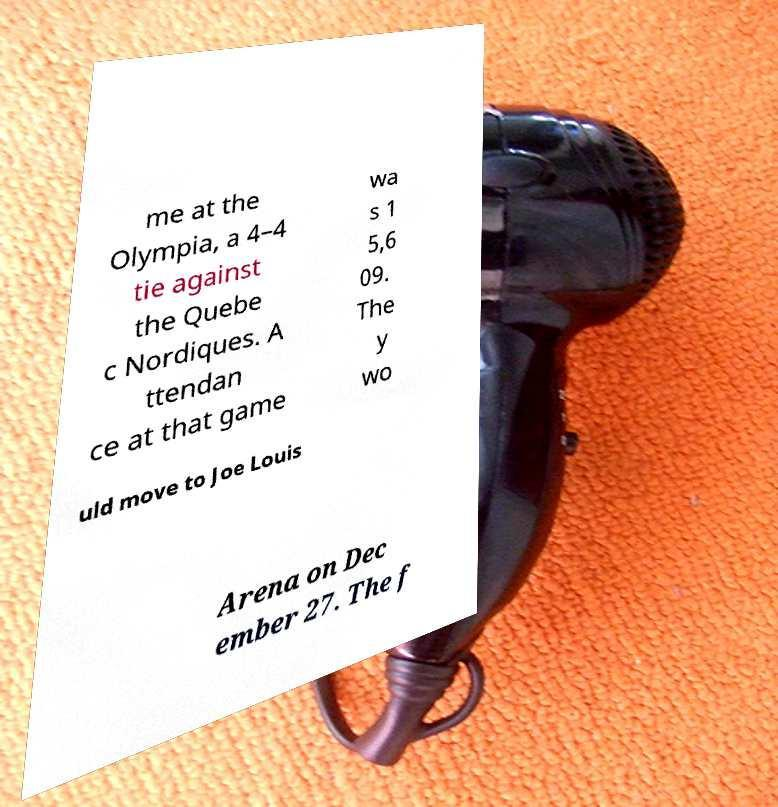What messages or text are displayed in this image? I need them in a readable, typed format. me at the Olympia, a 4–4 tie against the Quebe c Nordiques. A ttendan ce at that game wa s 1 5,6 09. The y wo uld move to Joe Louis Arena on Dec ember 27. The f 